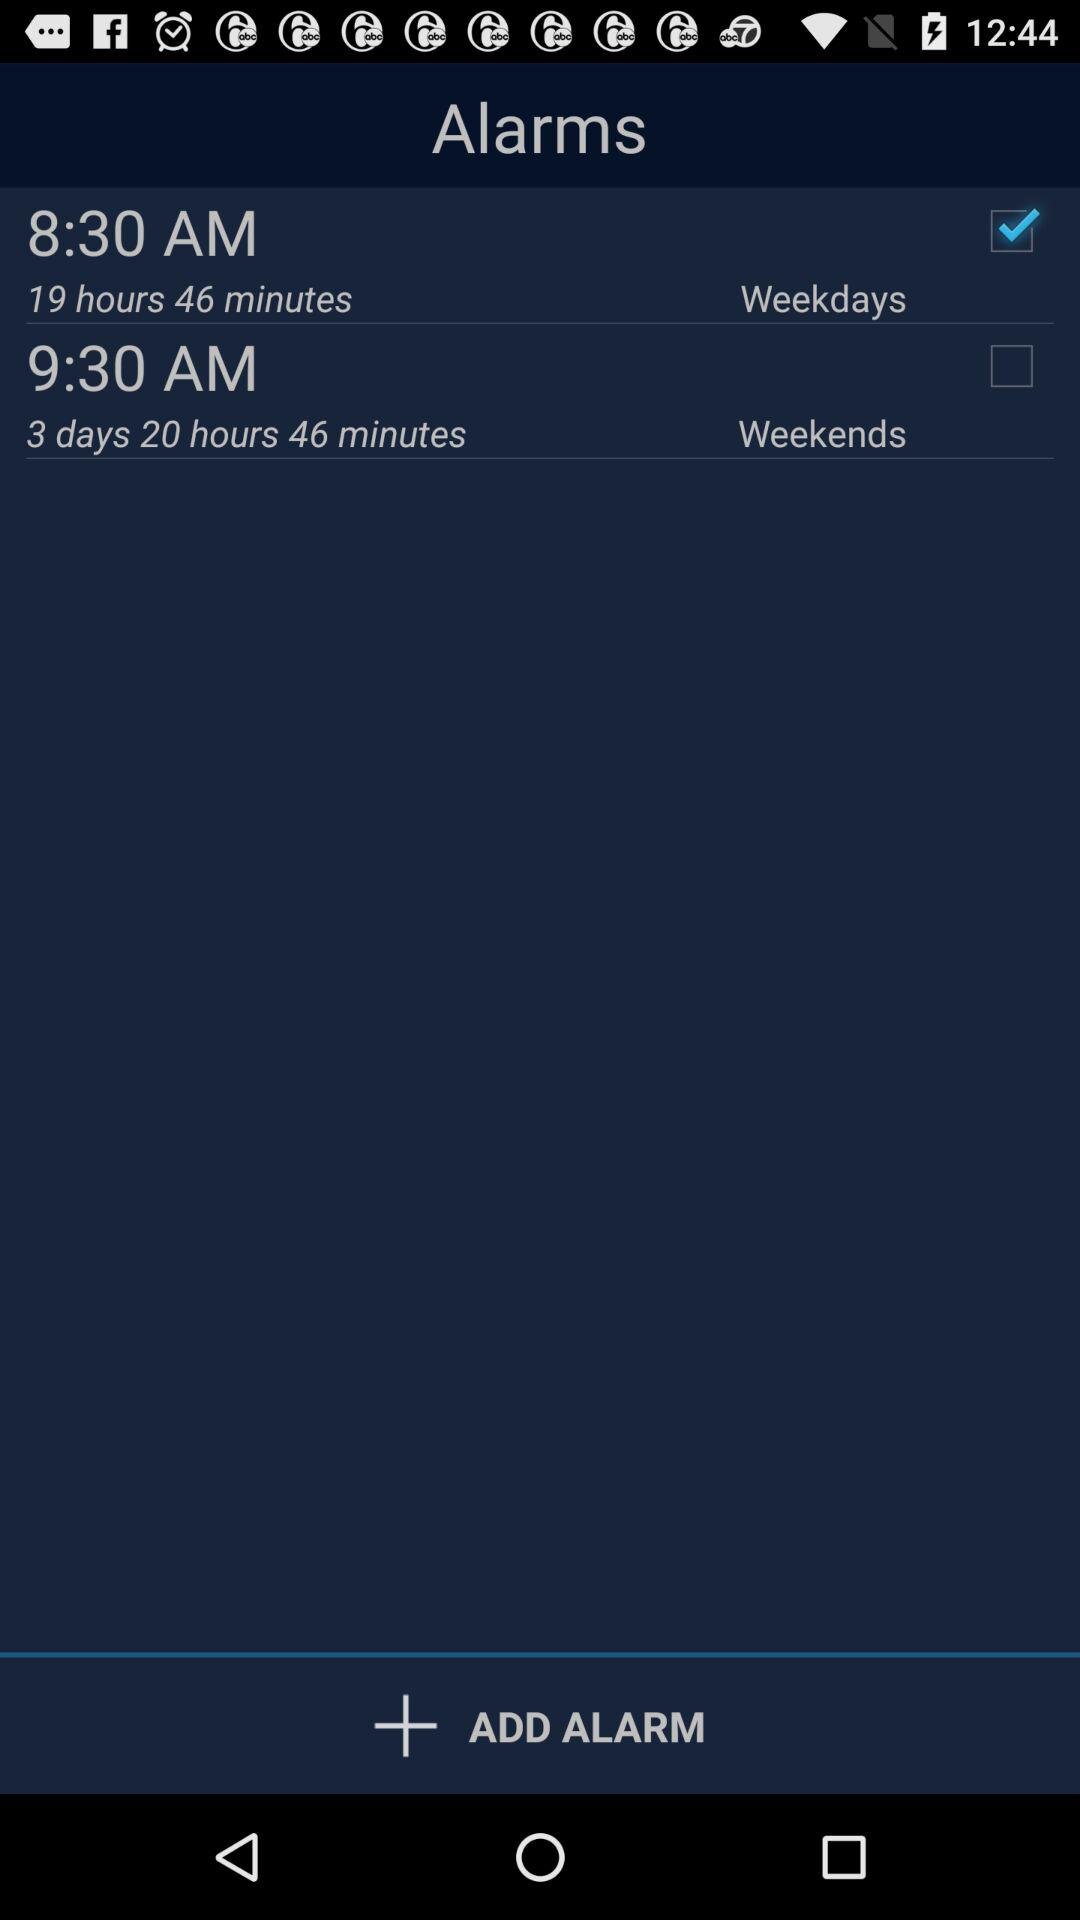What is the time left to ring the alarm on weekdays? The time left is 19 hours and 46 minutes. 